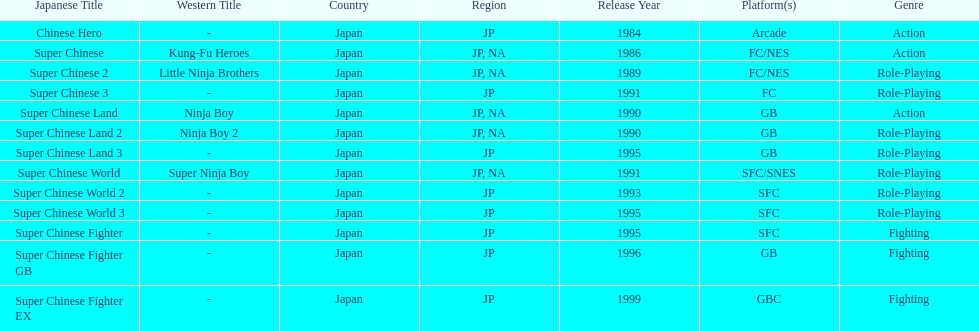When was the last super chinese game released? 1999. 